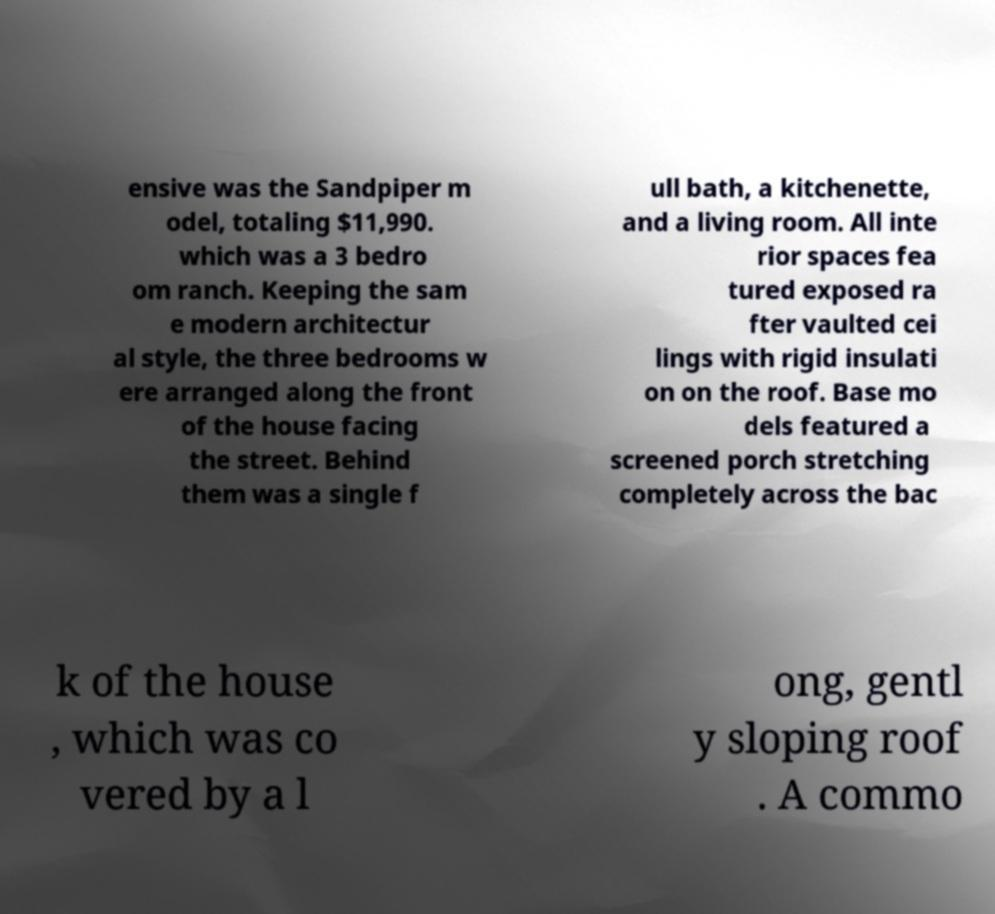Please read and relay the text visible in this image. What does it say? ensive was the Sandpiper m odel, totaling $11,990. which was a 3 bedro om ranch. Keeping the sam e modern architectur al style, the three bedrooms w ere arranged along the front of the house facing the street. Behind them was a single f ull bath, a kitchenette, and a living room. All inte rior spaces fea tured exposed ra fter vaulted cei lings with rigid insulati on on the roof. Base mo dels featured a screened porch stretching completely across the bac k of the house , which was co vered by a l ong, gentl y sloping roof . A commo 